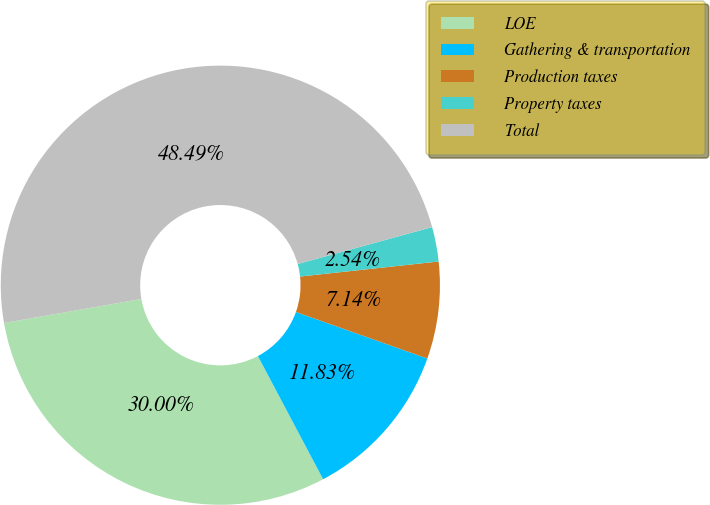<chart> <loc_0><loc_0><loc_500><loc_500><pie_chart><fcel>LOE<fcel>Gathering & transportation<fcel>Production taxes<fcel>Property taxes<fcel>Total<nl><fcel>30.0%<fcel>11.83%<fcel>7.14%<fcel>2.54%<fcel>48.49%<nl></chart> 